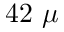Convert formula to latex. <formula><loc_0><loc_0><loc_500><loc_500>4 2 \ \mu</formula> 